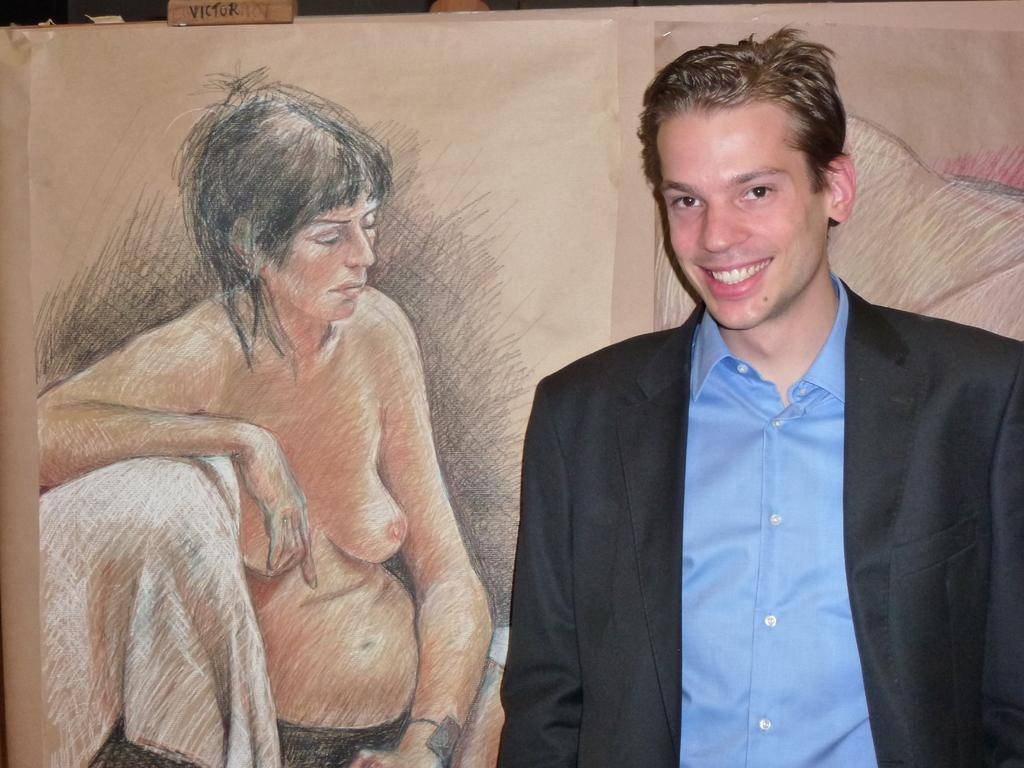Who or what is present in the image? There is a person in the image. What is the person wearing on their upper body? The person is wearing a blue shirt and a black coat. What can be seen in the background of the image? There is a painting of a woman in the background of the image. What type of plant can be seen growing on the person's head in the image? There is no plant visible on the person's head in the image. 